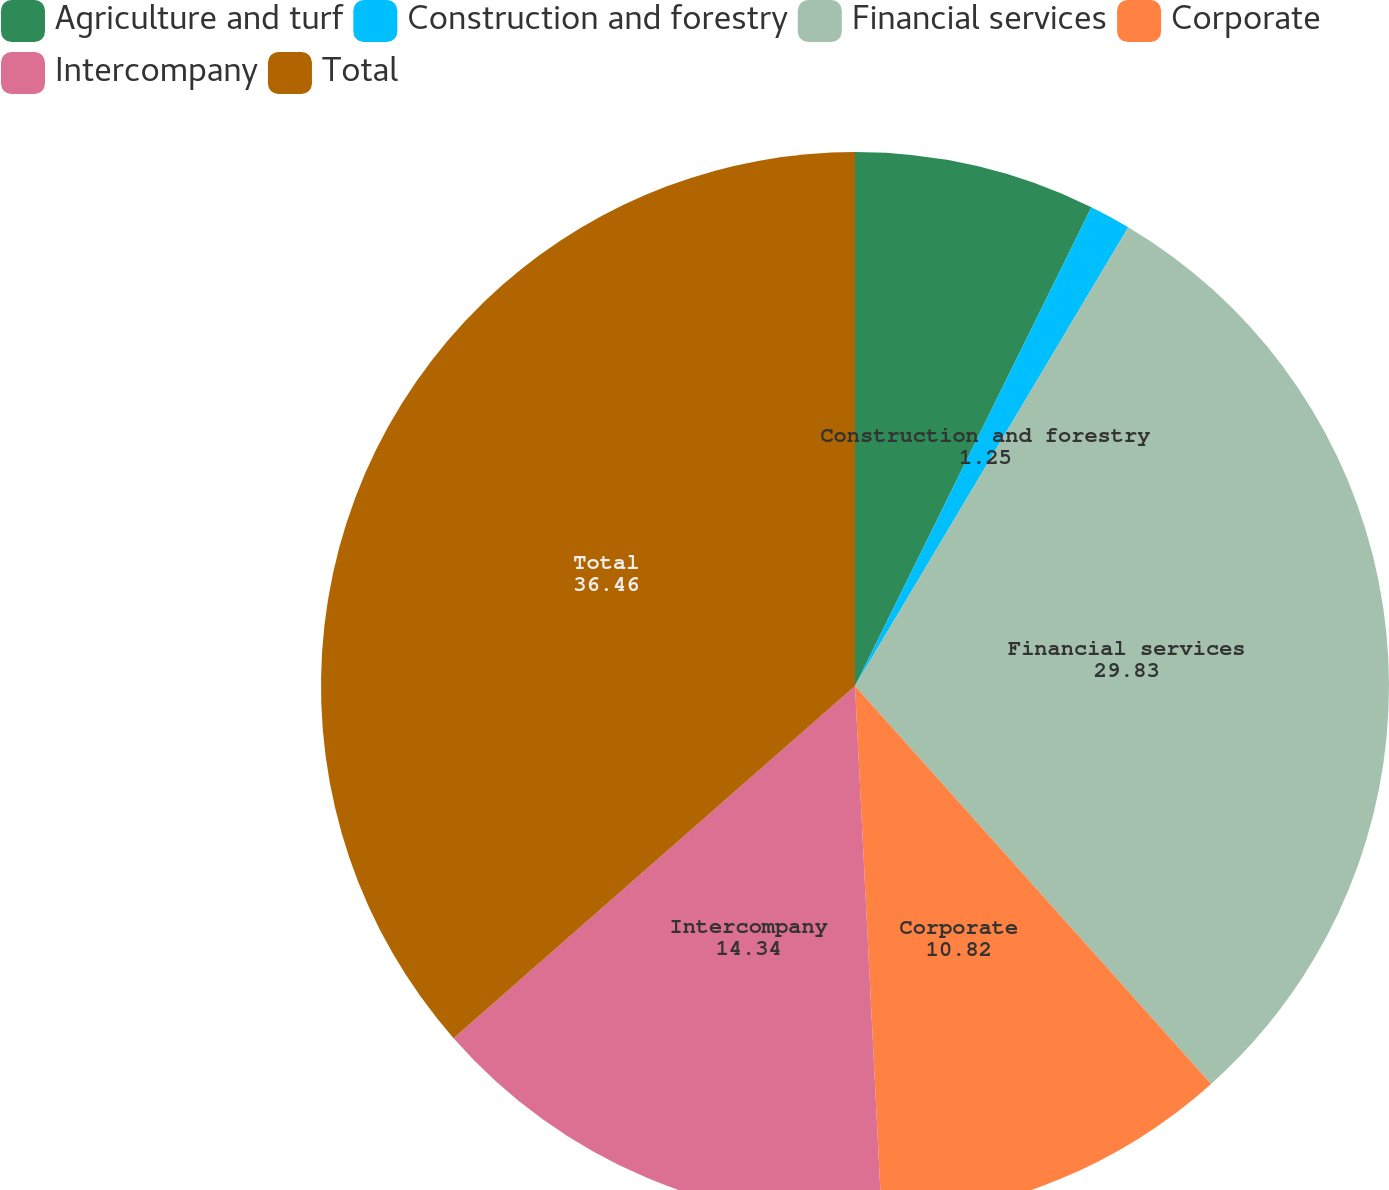Convert chart. <chart><loc_0><loc_0><loc_500><loc_500><pie_chart><fcel>Agriculture and turf<fcel>Construction and forestry<fcel>Financial services<fcel>Corporate<fcel>Intercompany<fcel>Total<nl><fcel>7.3%<fcel>1.25%<fcel>29.83%<fcel>10.82%<fcel>14.34%<fcel>36.46%<nl></chart> 